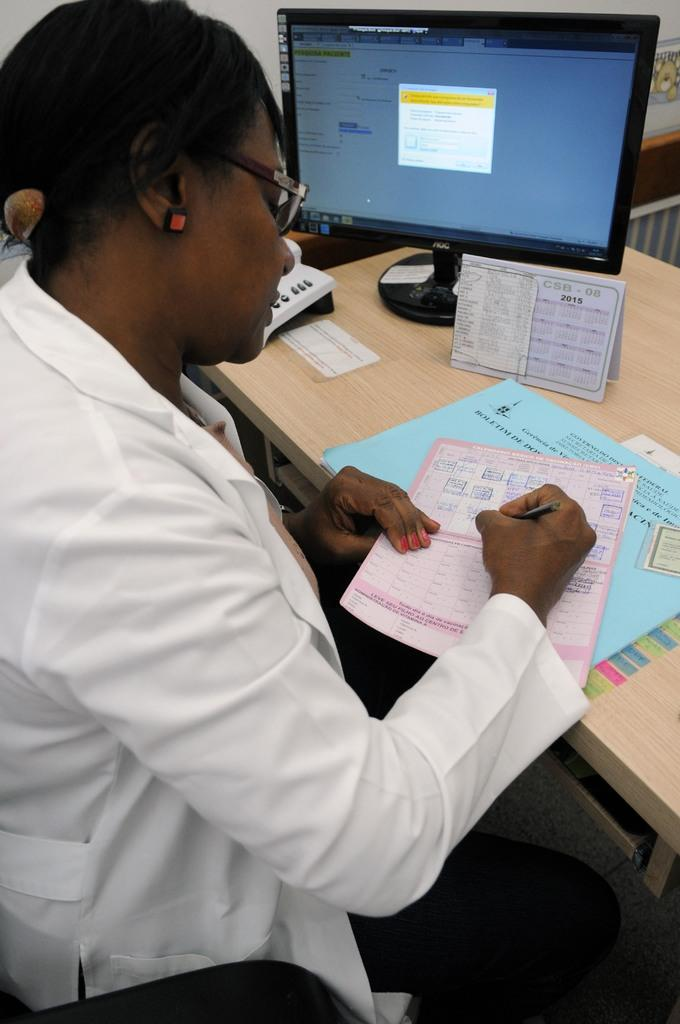<image>
Present a compact description of the photo's key features. a person at an office desk writing near a CSB 2015 calendar 